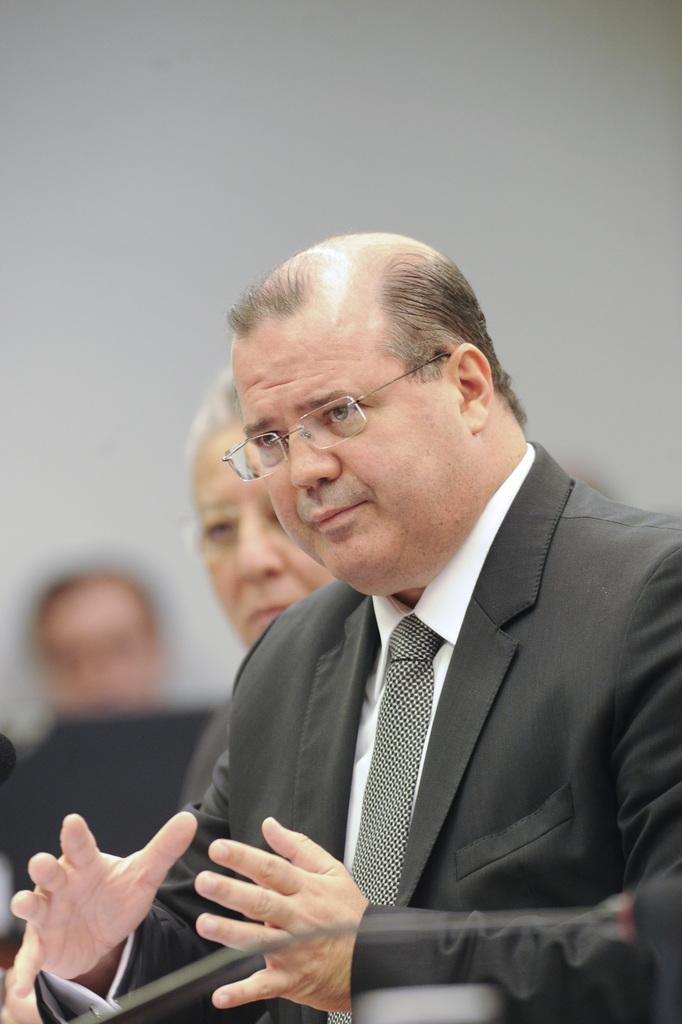Who is the main subject in the image? There is a man in the image. What accessory is the man wearing? The man is wearing glasses (specs). What object is located at the bottom of the image? There is a microphone (mic) at the bottom of the image. Can you describe the people in the background of the image? There are people in the background of the image, but their appearance is blurry. What type of muscle is the man exercising in the image? There is no indication of the man exercising or displaying any muscles in the image. 